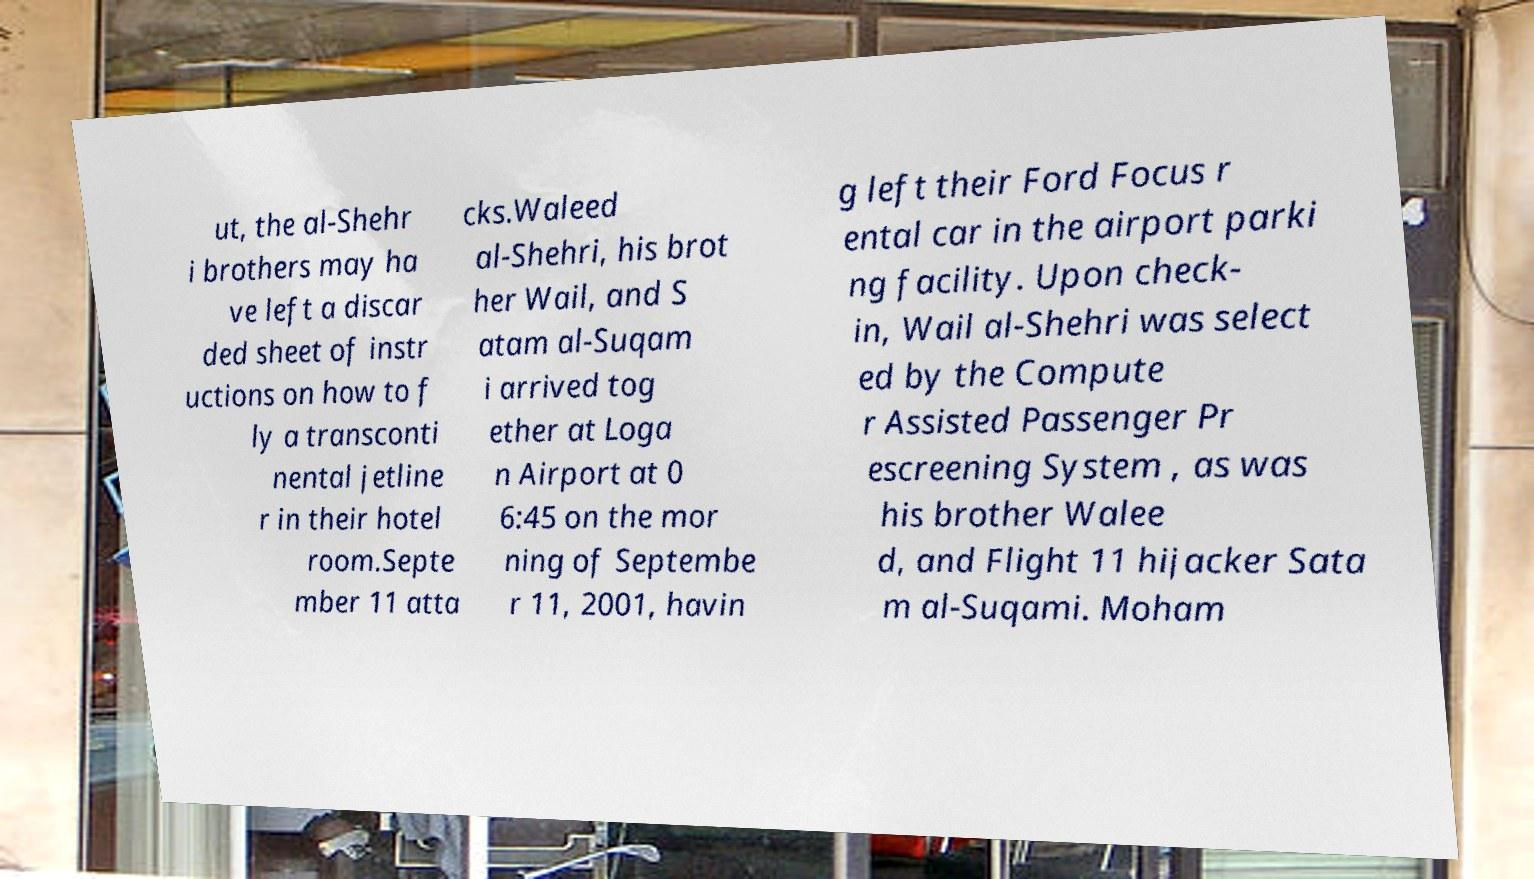Can you accurately transcribe the text from the provided image for me? ut, the al-Shehr i brothers may ha ve left a discar ded sheet of instr uctions on how to f ly a transconti nental jetline r in their hotel room.Septe mber 11 atta cks.Waleed al-Shehri, his brot her Wail, and S atam al-Suqam i arrived tog ether at Loga n Airport at 0 6:45 on the mor ning of Septembe r 11, 2001, havin g left their Ford Focus r ental car in the airport parki ng facility. Upon check- in, Wail al-Shehri was select ed by the Compute r Assisted Passenger Pr escreening System , as was his brother Walee d, and Flight 11 hijacker Sata m al-Suqami. Moham 